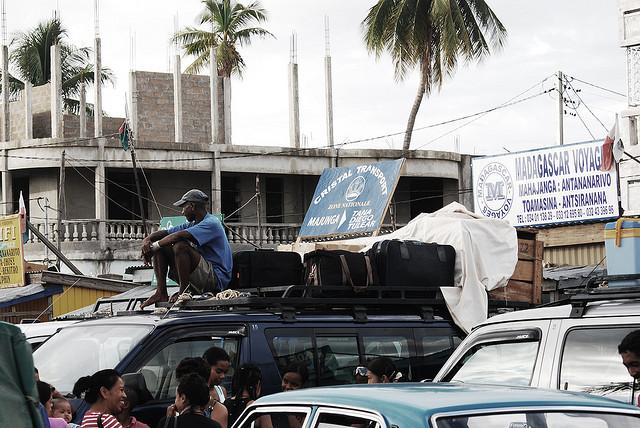These people are on what continent?

Choices:
A) asia
B) south america
C) africa
D) north america africa 